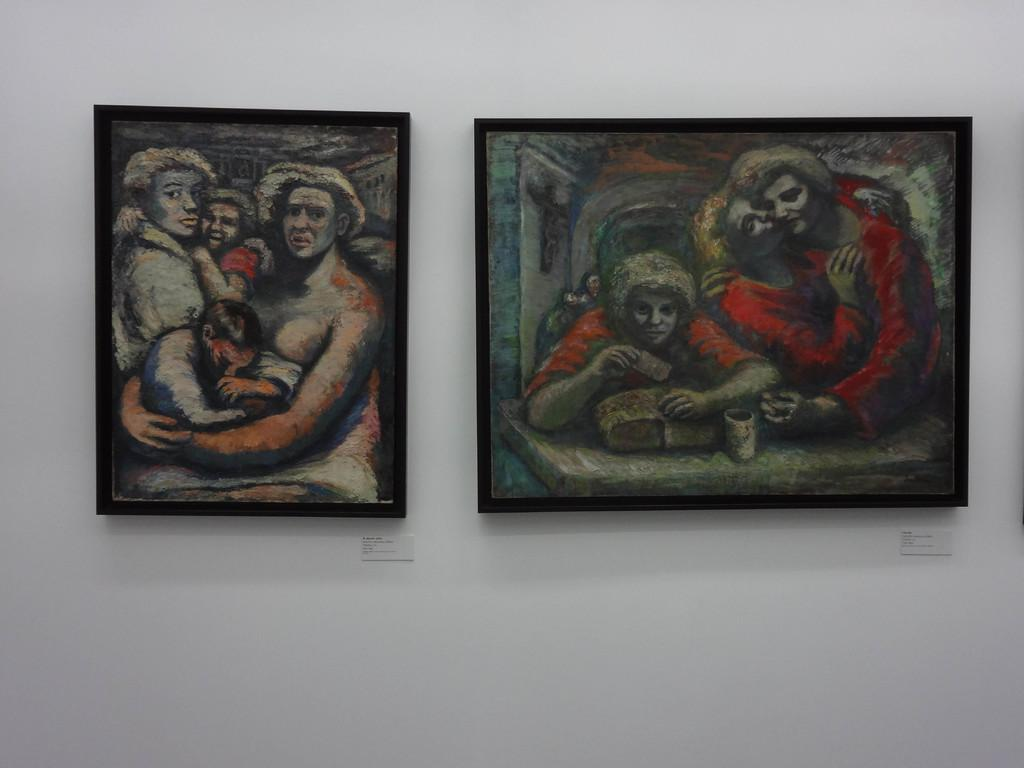How many photo frames are present in the image? There are two photo frames in the image. What is depicted in the photo frames? The photo frames contain paintings of persons. What is the color of the wall on which the photo frames are attached? The photo frames are attached to a white color wall. How much profit did the friends make from selling the paintings in the image? There is no information about profit or friends in the image, as it only features two photo frames with paintings of persons attached to a white wall. 